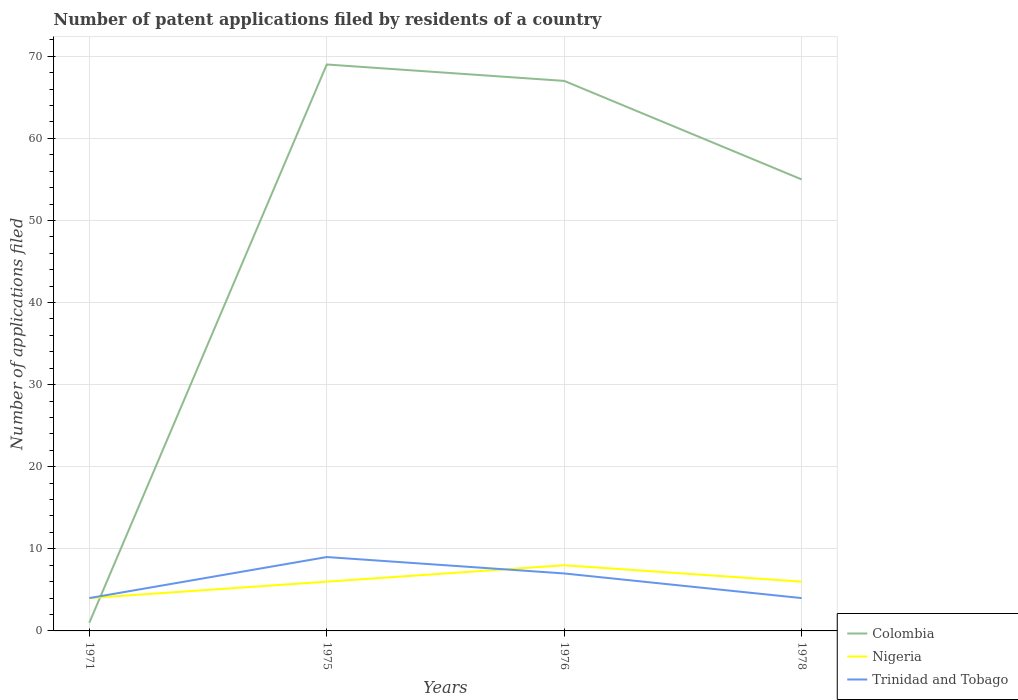How many different coloured lines are there?
Provide a short and direct response. 3. Does the line corresponding to Trinidad and Tobago intersect with the line corresponding to Colombia?
Provide a succinct answer. Yes. Across all years, what is the maximum number of applications filed in Nigeria?
Give a very brief answer. 4. In which year was the number of applications filed in Trinidad and Tobago maximum?
Offer a very short reply. 1971. What is the difference between the highest and the second highest number of applications filed in Trinidad and Tobago?
Provide a succinct answer. 5. What is the difference between the highest and the lowest number of applications filed in Trinidad and Tobago?
Your response must be concise. 2. How many lines are there?
Give a very brief answer. 3. How many years are there in the graph?
Your answer should be compact. 4. What is the difference between two consecutive major ticks on the Y-axis?
Keep it short and to the point. 10. Does the graph contain any zero values?
Your answer should be very brief. No. Does the graph contain grids?
Make the answer very short. Yes. How many legend labels are there?
Give a very brief answer. 3. How are the legend labels stacked?
Give a very brief answer. Vertical. What is the title of the graph?
Give a very brief answer. Number of patent applications filed by residents of a country. Does "Guam" appear as one of the legend labels in the graph?
Make the answer very short. No. What is the label or title of the X-axis?
Give a very brief answer. Years. What is the label or title of the Y-axis?
Offer a terse response. Number of applications filed. What is the Number of applications filed in Colombia in 1975?
Your response must be concise. 69. What is the Number of applications filed in Trinidad and Tobago in 1975?
Offer a terse response. 9. What is the Number of applications filed of Nigeria in 1976?
Give a very brief answer. 8. What is the Number of applications filed in Trinidad and Tobago in 1976?
Offer a very short reply. 7. What is the Number of applications filed in Colombia in 1978?
Provide a succinct answer. 55. What is the Number of applications filed of Nigeria in 1978?
Offer a terse response. 6. What is the Number of applications filed of Trinidad and Tobago in 1978?
Provide a succinct answer. 4. Across all years, what is the maximum Number of applications filed of Trinidad and Tobago?
Give a very brief answer. 9. Across all years, what is the minimum Number of applications filed of Trinidad and Tobago?
Give a very brief answer. 4. What is the total Number of applications filed of Colombia in the graph?
Your answer should be compact. 192. What is the total Number of applications filed in Nigeria in the graph?
Your response must be concise. 24. What is the difference between the Number of applications filed in Colombia in 1971 and that in 1975?
Provide a short and direct response. -68. What is the difference between the Number of applications filed of Colombia in 1971 and that in 1976?
Your response must be concise. -66. What is the difference between the Number of applications filed in Trinidad and Tobago in 1971 and that in 1976?
Provide a short and direct response. -3. What is the difference between the Number of applications filed in Colombia in 1971 and that in 1978?
Your answer should be compact. -54. What is the difference between the Number of applications filed in Trinidad and Tobago in 1975 and that in 1976?
Your answer should be very brief. 2. What is the difference between the Number of applications filed in Colombia in 1971 and the Number of applications filed in Nigeria in 1975?
Give a very brief answer. -5. What is the difference between the Number of applications filed of Colombia in 1971 and the Number of applications filed of Trinidad and Tobago in 1975?
Ensure brevity in your answer.  -8. What is the difference between the Number of applications filed in Colombia in 1971 and the Number of applications filed in Nigeria in 1978?
Ensure brevity in your answer.  -5. What is the difference between the Number of applications filed of Colombia in 1971 and the Number of applications filed of Trinidad and Tobago in 1978?
Make the answer very short. -3. What is the difference between the Number of applications filed of Colombia in 1975 and the Number of applications filed of Trinidad and Tobago in 1976?
Give a very brief answer. 62. What is the difference between the Number of applications filed in Nigeria in 1975 and the Number of applications filed in Trinidad and Tobago in 1976?
Keep it short and to the point. -1. What is the difference between the Number of applications filed in Colombia in 1975 and the Number of applications filed in Nigeria in 1978?
Provide a short and direct response. 63. What is the difference between the Number of applications filed of Colombia in 1975 and the Number of applications filed of Trinidad and Tobago in 1978?
Provide a short and direct response. 65. What is the difference between the Number of applications filed in Nigeria in 1975 and the Number of applications filed in Trinidad and Tobago in 1978?
Offer a very short reply. 2. What is the difference between the Number of applications filed of Colombia in 1976 and the Number of applications filed of Trinidad and Tobago in 1978?
Offer a very short reply. 63. What is the average Number of applications filed in Colombia per year?
Keep it short and to the point. 48. In the year 1971, what is the difference between the Number of applications filed in Colombia and Number of applications filed in Nigeria?
Ensure brevity in your answer.  -3. In the year 1971, what is the difference between the Number of applications filed of Colombia and Number of applications filed of Trinidad and Tobago?
Provide a short and direct response. -3. In the year 1975, what is the difference between the Number of applications filed of Colombia and Number of applications filed of Nigeria?
Your response must be concise. 63. In the year 1975, what is the difference between the Number of applications filed of Colombia and Number of applications filed of Trinidad and Tobago?
Provide a succinct answer. 60. In the year 1975, what is the difference between the Number of applications filed in Nigeria and Number of applications filed in Trinidad and Tobago?
Your answer should be very brief. -3. In the year 1976, what is the difference between the Number of applications filed in Colombia and Number of applications filed in Trinidad and Tobago?
Your answer should be compact. 60. In the year 1976, what is the difference between the Number of applications filed of Nigeria and Number of applications filed of Trinidad and Tobago?
Your response must be concise. 1. In the year 1978, what is the difference between the Number of applications filed of Colombia and Number of applications filed of Nigeria?
Give a very brief answer. 49. In the year 1978, what is the difference between the Number of applications filed in Colombia and Number of applications filed in Trinidad and Tobago?
Offer a terse response. 51. In the year 1978, what is the difference between the Number of applications filed of Nigeria and Number of applications filed of Trinidad and Tobago?
Make the answer very short. 2. What is the ratio of the Number of applications filed in Colombia in 1971 to that in 1975?
Ensure brevity in your answer.  0.01. What is the ratio of the Number of applications filed of Trinidad and Tobago in 1971 to that in 1975?
Make the answer very short. 0.44. What is the ratio of the Number of applications filed of Colombia in 1971 to that in 1976?
Keep it short and to the point. 0.01. What is the ratio of the Number of applications filed of Nigeria in 1971 to that in 1976?
Provide a succinct answer. 0.5. What is the ratio of the Number of applications filed in Trinidad and Tobago in 1971 to that in 1976?
Your answer should be very brief. 0.57. What is the ratio of the Number of applications filed in Colombia in 1971 to that in 1978?
Ensure brevity in your answer.  0.02. What is the ratio of the Number of applications filed in Trinidad and Tobago in 1971 to that in 1978?
Your answer should be very brief. 1. What is the ratio of the Number of applications filed of Colombia in 1975 to that in 1976?
Your answer should be very brief. 1.03. What is the ratio of the Number of applications filed of Nigeria in 1975 to that in 1976?
Ensure brevity in your answer.  0.75. What is the ratio of the Number of applications filed of Colombia in 1975 to that in 1978?
Offer a very short reply. 1.25. What is the ratio of the Number of applications filed of Nigeria in 1975 to that in 1978?
Your answer should be compact. 1. What is the ratio of the Number of applications filed of Trinidad and Tobago in 1975 to that in 1978?
Your answer should be compact. 2.25. What is the ratio of the Number of applications filed in Colombia in 1976 to that in 1978?
Give a very brief answer. 1.22. What is the ratio of the Number of applications filed of Trinidad and Tobago in 1976 to that in 1978?
Offer a terse response. 1.75. What is the difference between the highest and the second highest Number of applications filed in Colombia?
Give a very brief answer. 2. What is the difference between the highest and the lowest Number of applications filed of Colombia?
Make the answer very short. 68. 